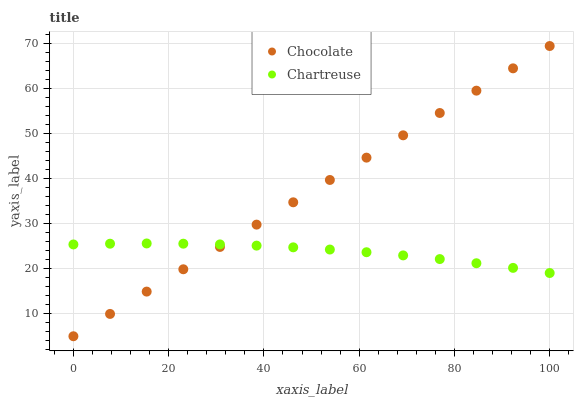Does Chartreuse have the minimum area under the curve?
Answer yes or no. Yes. Does Chocolate have the maximum area under the curve?
Answer yes or no. Yes. Does Chocolate have the minimum area under the curve?
Answer yes or no. No. Is Chocolate the smoothest?
Answer yes or no. Yes. Is Chartreuse the roughest?
Answer yes or no. Yes. Is Chocolate the roughest?
Answer yes or no. No. Does Chocolate have the lowest value?
Answer yes or no. Yes. Does Chocolate have the highest value?
Answer yes or no. Yes. Does Chartreuse intersect Chocolate?
Answer yes or no. Yes. Is Chartreuse less than Chocolate?
Answer yes or no. No. Is Chartreuse greater than Chocolate?
Answer yes or no. No. 